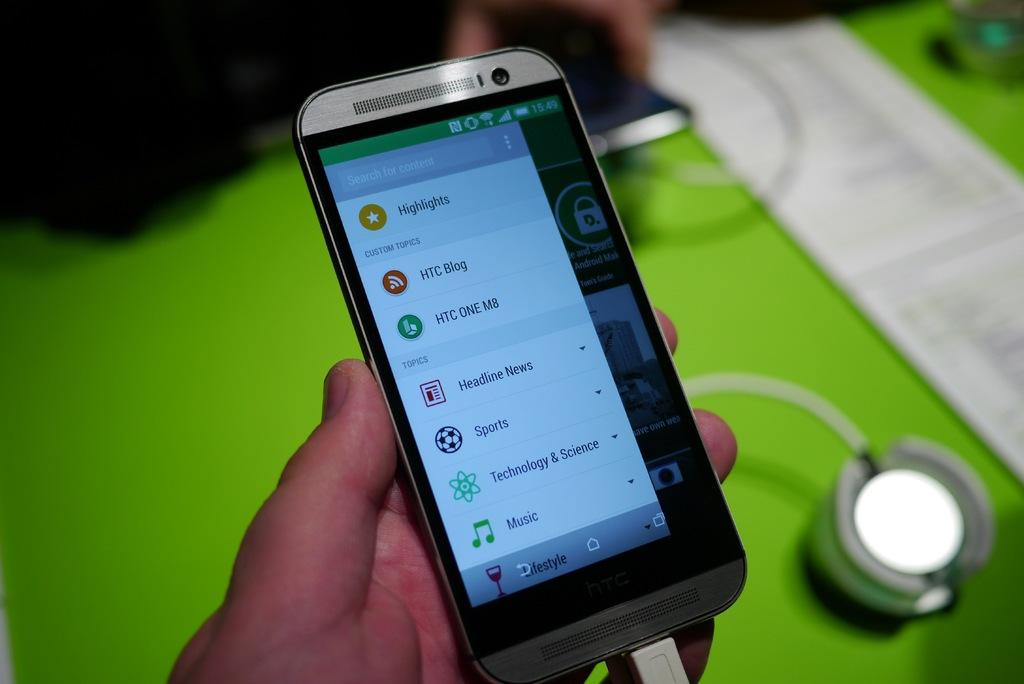<image>
Create a compact narrative representing the image presented. A person is holding a silver cell phone that has a tab for Sports, Technology & Science, and Music. 